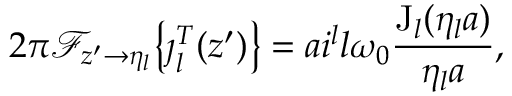Convert formula to latex. <formula><loc_0><loc_0><loc_500><loc_500>2 \pi \mathcal { F } _ { z ^ { \prime } \rightarrow \eta _ { l } } \left \{ \jmath _ { l } ^ { T } ( z ^ { \prime } ) \right \} = a i ^ { l } l \omega _ { 0 } \frac { J _ { l } ( \eta _ { l } a ) } { \eta _ { l } a } ,</formula> 